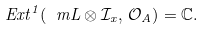Convert formula to latex. <formula><loc_0><loc_0><loc_500><loc_500>E x t ^ { 1 } ( \ m L \otimes \mathcal { I } _ { x } , \, \mathcal { O } _ { A } ) = \mathbb { C } .</formula> 